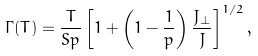Convert formula to latex. <formula><loc_0><loc_0><loc_500><loc_500>\Gamma ( T ) = \frac { T } { S p } \left [ 1 + \left ( 1 - \frac { 1 } { p } \right ) \frac { J _ { \perp } } { J } \right ] ^ { 1 / 2 } ,</formula> 